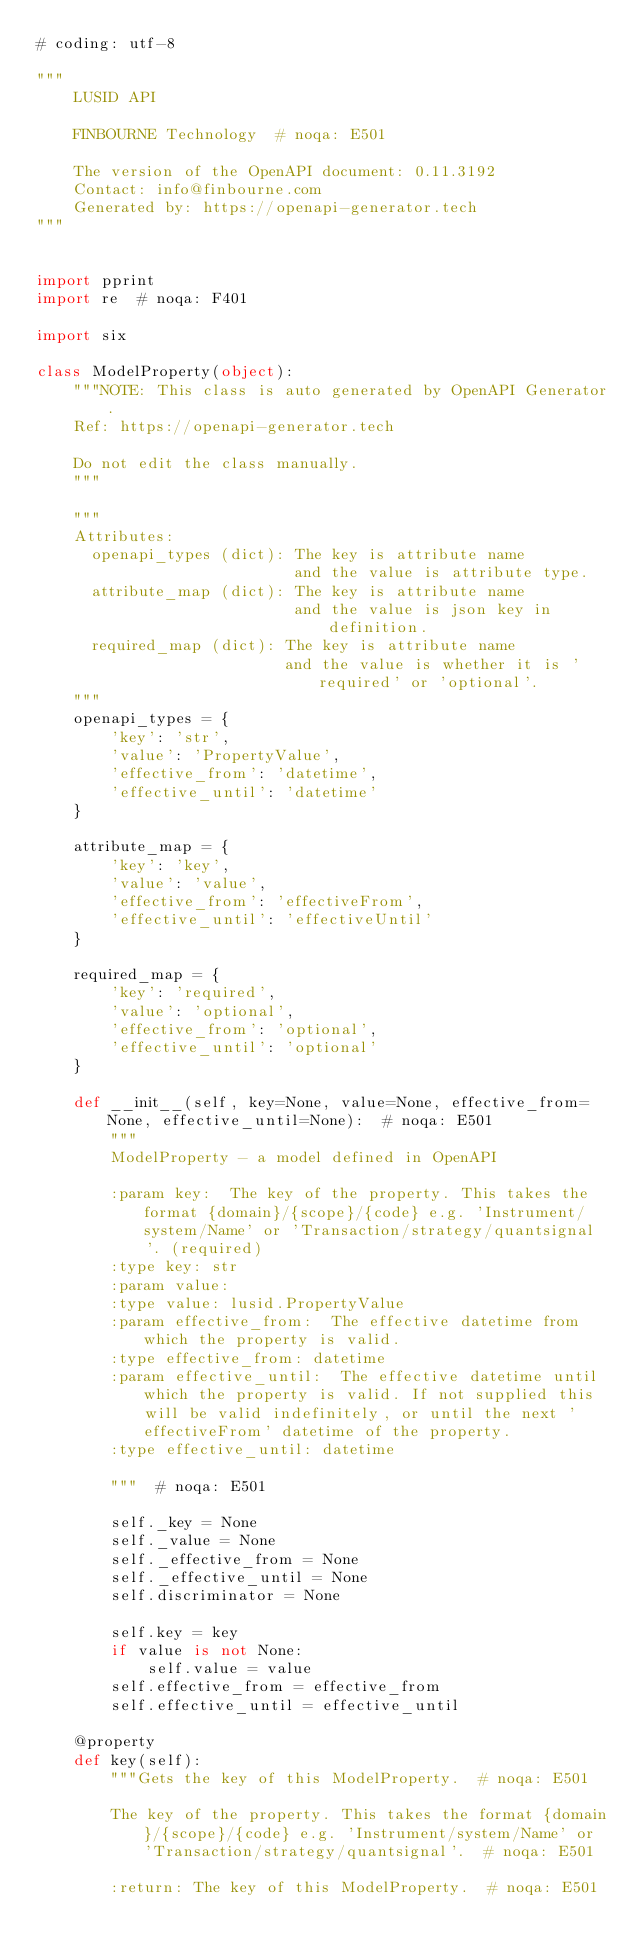Convert code to text. <code><loc_0><loc_0><loc_500><loc_500><_Python_># coding: utf-8

"""
    LUSID API

    FINBOURNE Technology  # noqa: E501

    The version of the OpenAPI document: 0.11.3192
    Contact: info@finbourne.com
    Generated by: https://openapi-generator.tech
"""


import pprint
import re  # noqa: F401

import six

class ModelProperty(object):
    """NOTE: This class is auto generated by OpenAPI Generator.
    Ref: https://openapi-generator.tech

    Do not edit the class manually.
    """

    """
    Attributes:
      openapi_types (dict): The key is attribute name
                            and the value is attribute type.
      attribute_map (dict): The key is attribute name
                            and the value is json key in definition.
      required_map (dict): The key is attribute name
                           and the value is whether it is 'required' or 'optional'.
    """
    openapi_types = {
        'key': 'str',
        'value': 'PropertyValue',
        'effective_from': 'datetime',
        'effective_until': 'datetime'
    }

    attribute_map = {
        'key': 'key',
        'value': 'value',
        'effective_from': 'effectiveFrom',
        'effective_until': 'effectiveUntil'
    }

    required_map = {
        'key': 'required',
        'value': 'optional',
        'effective_from': 'optional',
        'effective_until': 'optional'
    }

    def __init__(self, key=None, value=None, effective_from=None, effective_until=None):  # noqa: E501
        """
        ModelProperty - a model defined in OpenAPI

        :param key:  The key of the property. This takes the format {domain}/{scope}/{code} e.g. 'Instrument/system/Name' or 'Transaction/strategy/quantsignal'. (required)
        :type key: str
        :param value: 
        :type value: lusid.PropertyValue
        :param effective_from:  The effective datetime from which the property is valid.
        :type effective_from: datetime
        :param effective_until:  The effective datetime until which the property is valid. If not supplied this will be valid indefinitely, or until the next 'effectiveFrom' datetime of the property.
        :type effective_until: datetime

        """  # noqa: E501

        self._key = None
        self._value = None
        self._effective_from = None
        self._effective_until = None
        self.discriminator = None

        self.key = key
        if value is not None:
            self.value = value
        self.effective_from = effective_from
        self.effective_until = effective_until

    @property
    def key(self):
        """Gets the key of this ModelProperty.  # noqa: E501

        The key of the property. This takes the format {domain}/{scope}/{code} e.g. 'Instrument/system/Name' or 'Transaction/strategy/quantsignal'.  # noqa: E501

        :return: The key of this ModelProperty.  # noqa: E501</code> 